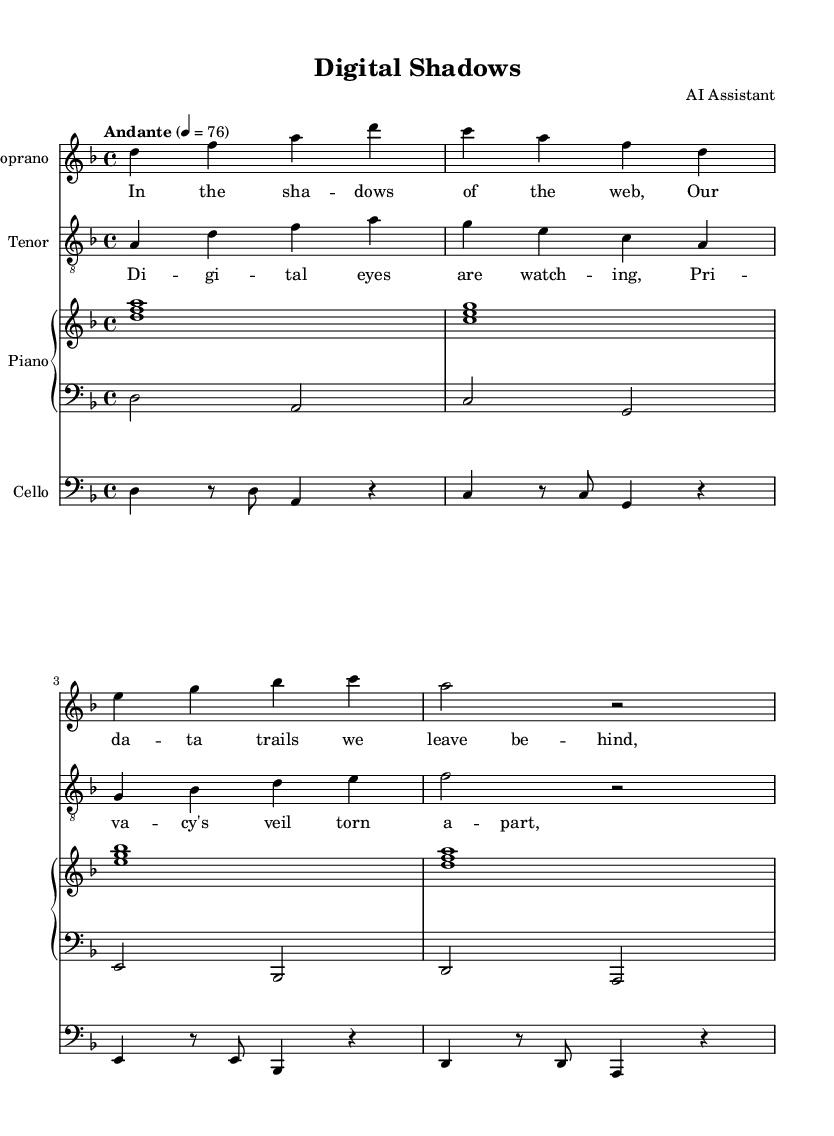What is the key signature of this music? The key signature is indicated at the beginning of the score, showing two flats (B♭ and E♭), which corresponds to D minor.
Answer: D minor What is the time signature of this piece? The time signature is located at the beginning of the score, written as "4/4", meaning there are four beats in a measure.
Answer: 4/4 What is the tempo marking for this opera? The tempo marking is found at the start of the piece, described as "Andante" with a metronome marking of 76, indicating a moderately slow tempo.
Answer: Andante 76 Which instruments are featured in this score? The instruments are indicated by their respective staves: Soprano, Tenor, Cello, and Piano (with both right hand and left hand parts).
Answer: Soprano, Tenor, Cello, Piano How many measures are assigned to the Soprano part? Counting the measures in the Soprano staff shows 4 distinct measures, as separated by the vertical bar lines.
Answer: 4 What is the theme explored in the lyrics of this opera? The lyrics focus on themes of digital surveillance and privacy, as indicated by phrases like "Digital eyes are watching" and references to data trails.
Answer: Digital surveillance and privacy What vocal range does the Tenor part encompass in this score? The Tenor part is written in a higher octave, indicating a typical male vocal range that spans from A4 to E5.
Answer: A4 to E5 